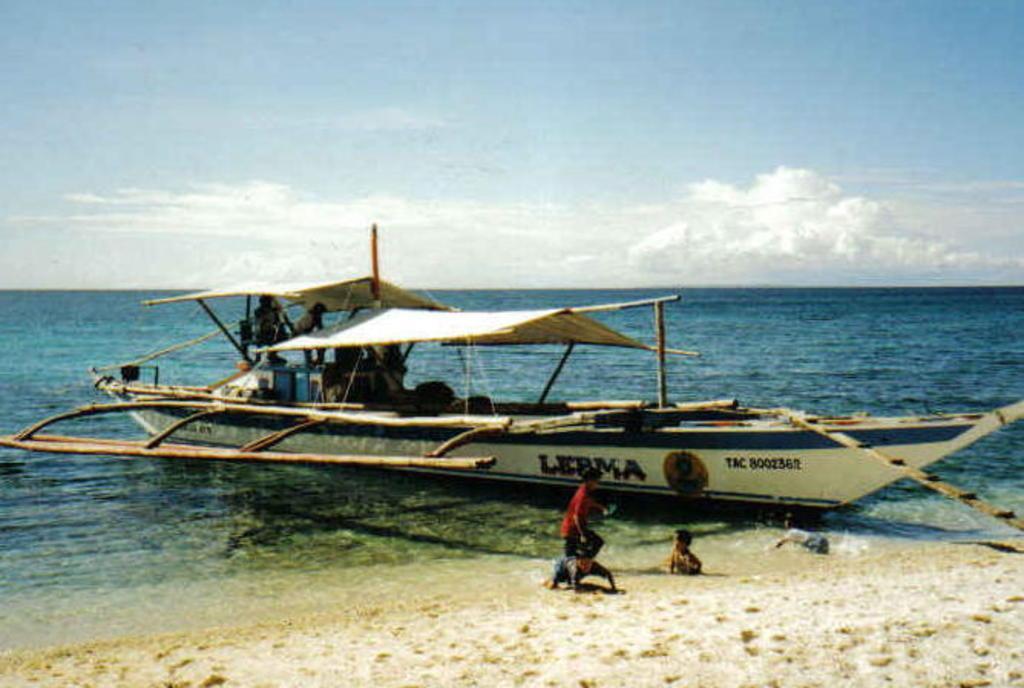In one or two sentences, can you explain what this image depicts? In this picture we can see three kids near the sea shore. There are a few tents, people and other objects visible on the boat. We can see an object on the right side. Sky is blue in color and cloudy. 